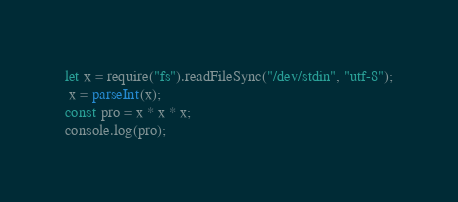Convert code to text. <code><loc_0><loc_0><loc_500><loc_500><_JavaScript_>let x = require("fs").readFileSync("/dev/stdin", "utf-8");
 x = parseInt(x);
const pro = x * x * x;
console.log(pro);
</code> 